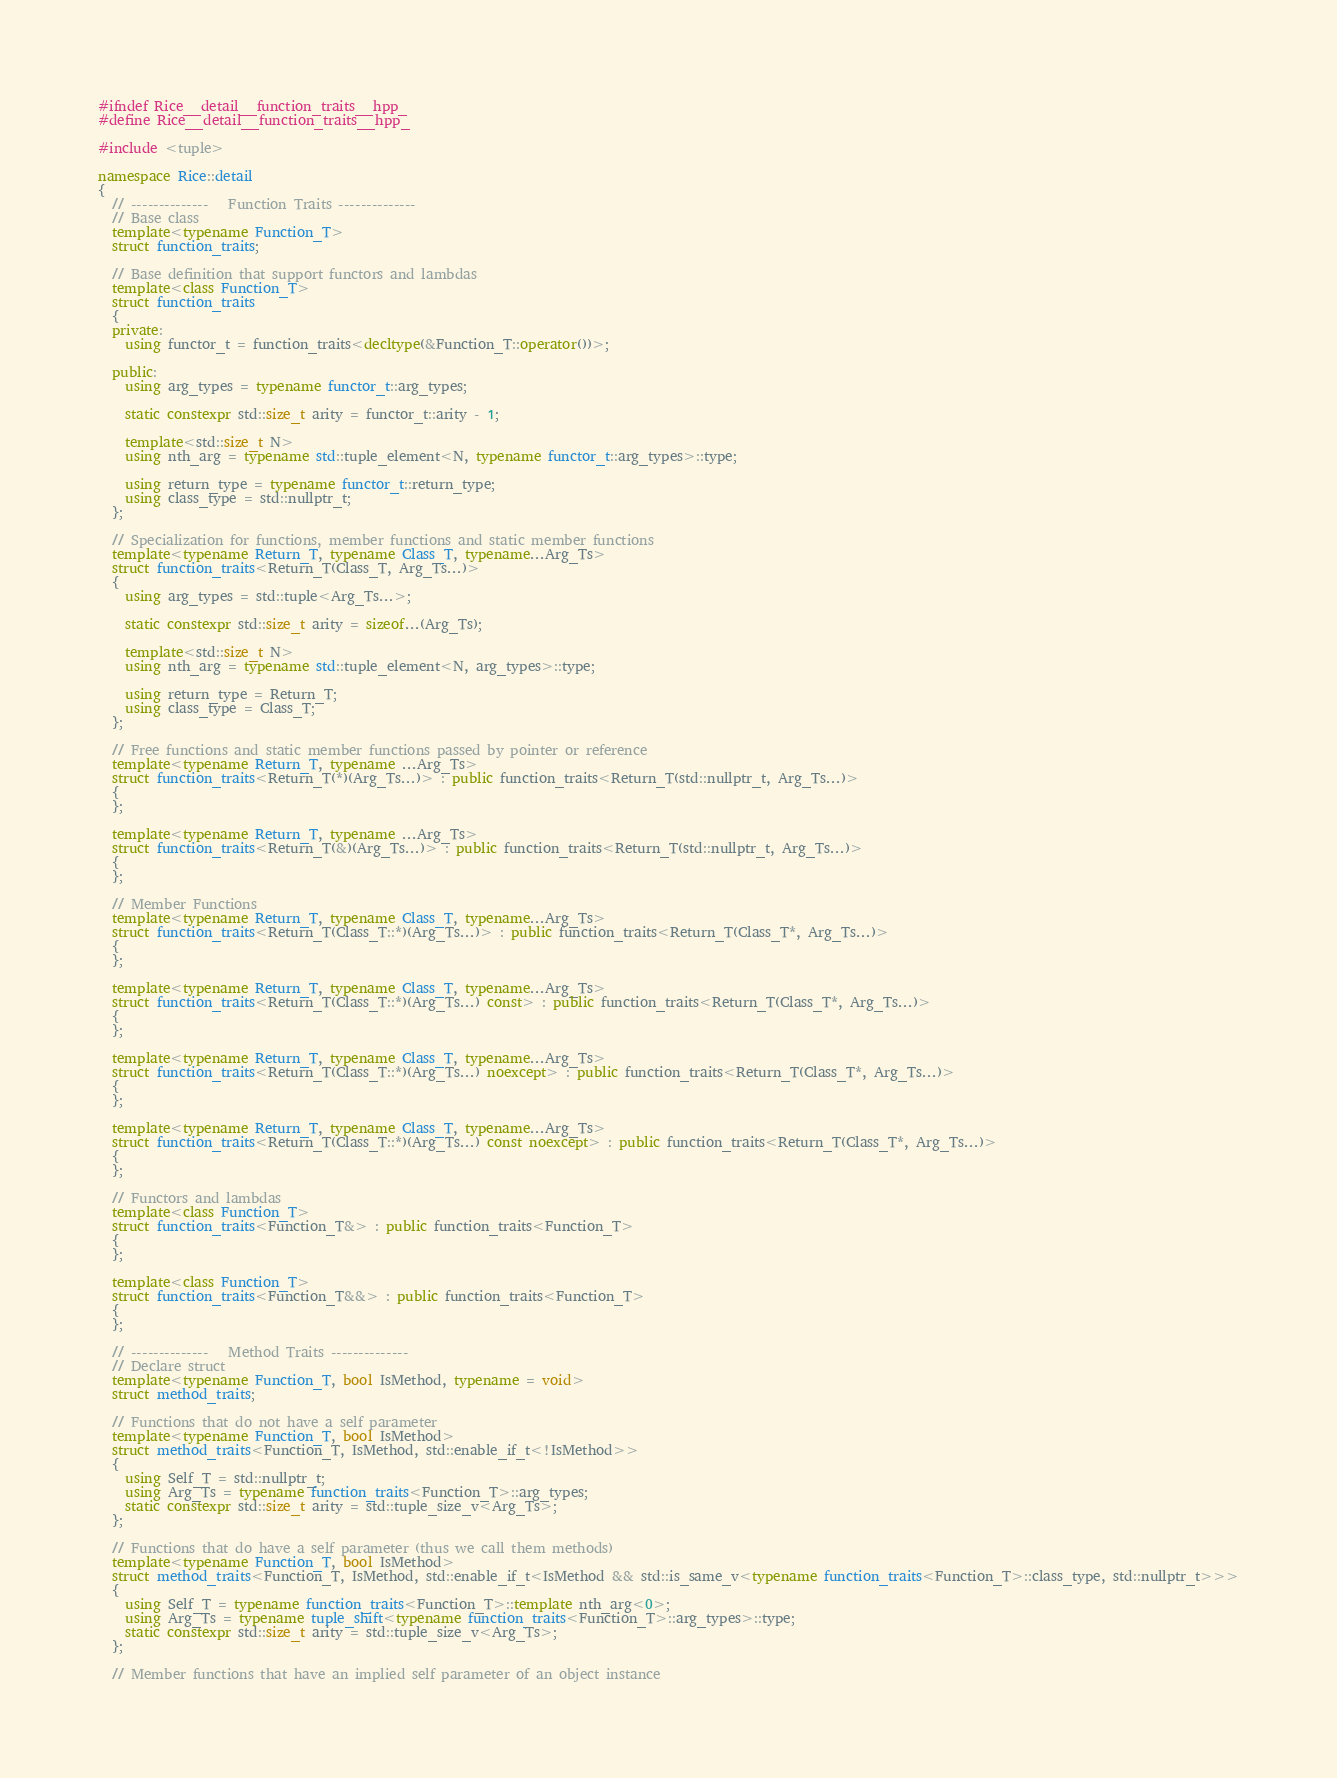Convert code to text. <code><loc_0><loc_0><loc_500><loc_500><_C++_>#ifndef Rice__detail__function_traits__hpp_
#define Rice__detail__function_traits__hpp_

#include <tuple>

namespace Rice::detail
{
  // --------------   Function Traits --------------
  // Base class
  template<typename Function_T>
  struct function_traits;

  // Base definition that support functors and lambdas
  template<class Function_T>
  struct function_traits
  {
  private:
    using functor_t = function_traits<decltype(&Function_T::operator())>;

  public:
    using arg_types = typename functor_t::arg_types;

    static constexpr std::size_t arity = functor_t::arity - 1;

    template<std::size_t N>
    using nth_arg = typename std::tuple_element<N, typename functor_t::arg_types>::type;

    using return_type = typename functor_t::return_type;
    using class_type = std::nullptr_t;
  };

  // Specialization for functions, member functions and static member functions
  template<typename Return_T, typename Class_T, typename...Arg_Ts>
  struct function_traits<Return_T(Class_T, Arg_Ts...)>
  {
    using arg_types = std::tuple<Arg_Ts...>;

    static constexpr std::size_t arity = sizeof...(Arg_Ts);

    template<std::size_t N>
    using nth_arg = typename std::tuple_element<N, arg_types>::type;

    using return_type = Return_T;
    using class_type = Class_T;
  };

  // Free functions and static member functions passed by pointer or reference
  template<typename Return_T, typename ...Arg_Ts>
  struct function_traits<Return_T(*)(Arg_Ts...)> : public function_traits<Return_T(std::nullptr_t, Arg_Ts...)>
  {
  };
  
  template<typename Return_T, typename ...Arg_Ts>
  struct function_traits<Return_T(&)(Arg_Ts...)> : public function_traits<Return_T(std::nullptr_t, Arg_Ts...)>
  {
  };

  // Member Functions
  template<typename Return_T, typename Class_T, typename...Arg_Ts>
  struct function_traits<Return_T(Class_T::*)(Arg_Ts...)> : public function_traits<Return_T(Class_T*, Arg_Ts...)>
  {
  };

  template<typename Return_T, typename Class_T, typename...Arg_Ts>
  struct function_traits<Return_T(Class_T::*)(Arg_Ts...) const> : public function_traits<Return_T(Class_T*, Arg_Ts...)>
  {
  };

  template<typename Return_T, typename Class_T, typename...Arg_Ts>
  struct function_traits<Return_T(Class_T::*)(Arg_Ts...) noexcept> : public function_traits<Return_T(Class_T*, Arg_Ts...)>
  {
  };

  template<typename Return_T, typename Class_T, typename...Arg_Ts>
  struct function_traits<Return_T(Class_T::*)(Arg_Ts...) const noexcept> : public function_traits<Return_T(Class_T*, Arg_Ts...)>
  {
  };

  // Functors and lambdas
  template<class Function_T>
  struct function_traits<Function_T&> : public function_traits<Function_T>
  {
  };

  template<class Function_T>
  struct function_traits<Function_T&&> : public function_traits<Function_T>
  {
  };

  // --------------   Method Traits --------------
  // Declare struct
  template<typename Function_T, bool IsMethod, typename = void>
  struct method_traits;

  // Functions that do not have a self parameter
  template<typename Function_T, bool IsMethod>
  struct method_traits<Function_T, IsMethod, std::enable_if_t<!IsMethod>>
  {
    using Self_T = std::nullptr_t;
    using Arg_Ts = typename function_traits<Function_T>::arg_types;
    static constexpr std::size_t arity = std::tuple_size_v<Arg_Ts>;
  };

  // Functions that do have a self parameter (thus we call them methods)
  template<typename Function_T, bool IsMethod>
  struct method_traits<Function_T, IsMethod, std::enable_if_t<IsMethod && std::is_same_v<typename function_traits<Function_T>::class_type, std::nullptr_t>>>
  {
    using Self_T = typename function_traits<Function_T>::template nth_arg<0>;
    using Arg_Ts = typename tuple_shift<typename function_traits<Function_T>::arg_types>::type;
    static constexpr std::size_t arity = std::tuple_size_v<Arg_Ts>;
  };

  // Member functions that have an implied self parameter of an object instance</code> 